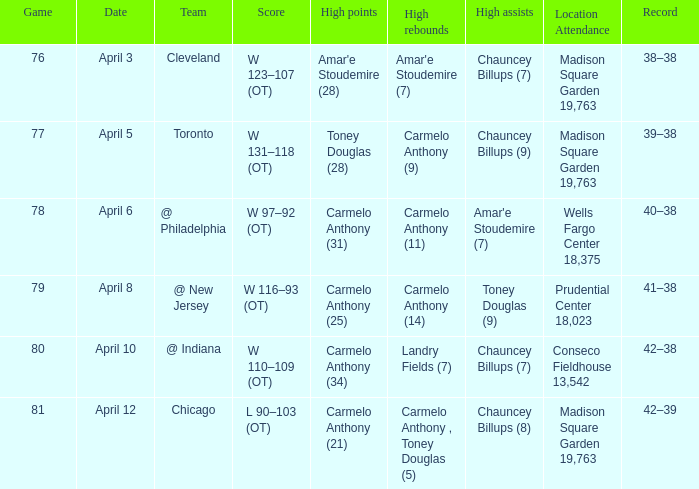Identify the place of presence on april Madison Square Garden 19,763. 